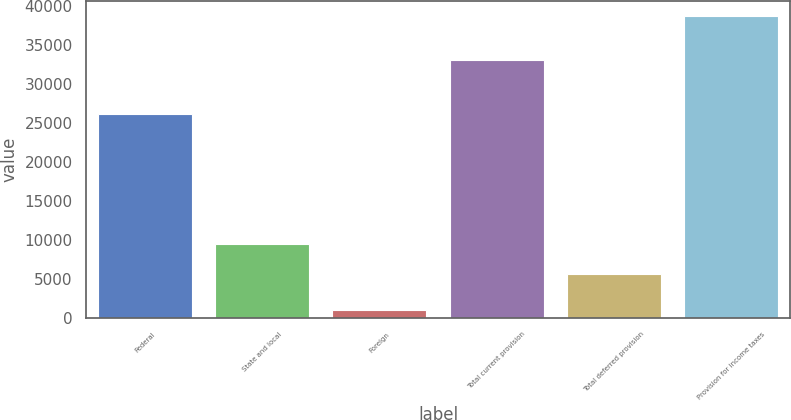<chart> <loc_0><loc_0><loc_500><loc_500><bar_chart><fcel>Federal<fcel>State and local<fcel>Foreign<fcel>Total current provision<fcel>Total deferred provision<fcel>Provision for income taxes<nl><fcel>26071<fcel>9444.3<fcel>1014<fcel>33043<fcel>5674<fcel>38717<nl></chart> 